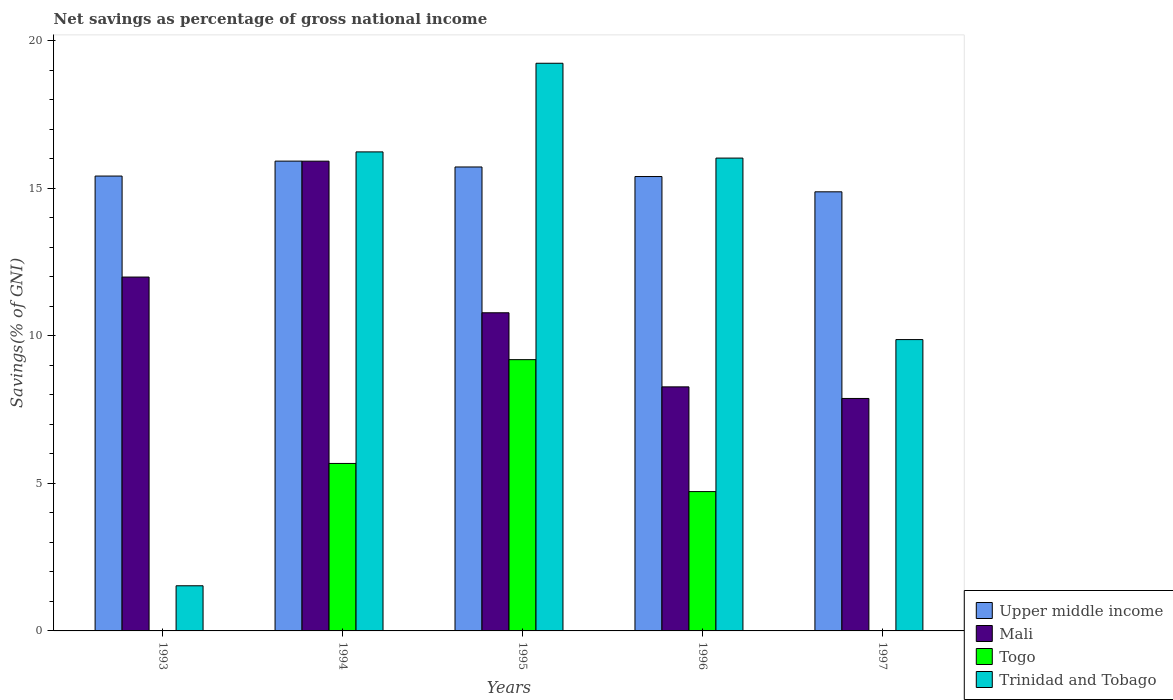Are the number of bars per tick equal to the number of legend labels?
Ensure brevity in your answer.  No. Are the number of bars on each tick of the X-axis equal?
Ensure brevity in your answer.  No. How many bars are there on the 4th tick from the left?
Ensure brevity in your answer.  4. What is the label of the 1st group of bars from the left?
Give a very brief answer. 1993. In how many cases, is the number of bars for a given year not equal to the number of legend labels?
Your answer should be compact. 2. Across all years, what is the maximum total savings in Upper middle income?
Your answer should be compact. 15.91. Across all years, what is the minimum total savings in Mali?
Your response must be concise. 7.87. In which year was the total savings in Mali maximum?
Make the answer very short. 1994. What is the total total savings in Mali in the graph?
Give a very brief answer. 54.82. What is the difference between the total savings in Trinidad and Tobago in 1994 and that in 1996?
Keep it short and to the point. 0.21. What is the difference between the total savings in Mali in 1993 and the total savings in Togo in 1995?
Your answer should be compact. 2.8. What is the average total savings in Mali per year?
Provide a short and direct response. 10.96. In the year 1994, what is the difference between the total savings in Togo and total savings in Mali?
Give a very brief answer. -10.24. In how many years, is the total savings in Trinidad and Tobago greater than 8 %?
Your answer should be very brief. 4. What is the ratio of the total savings in Upper middle income in 1993 to that in 1994?
Provide a succinct answer. 0.97. Is the difference between the total savings in Togo in 1995 and 1996 greater than the difference between the total savings in Mali in 1995 and 1996?
Give a very brief answer. Yes. What is the difference between the highest and the second highest total savings in Trinidad and Tobago?
Your answer should be very brief. 3. What is the difference between the highest and the lowest total savings in Upper middle income?
Keep it short and to the point. 1.04. In how many years, is the total savings in Upper middle income greater than the average total savings in Upper middle income taken over all years?
Make the answer very short. 2. Is the sum of the total savings in Upper middle income in 1995 and 1996 greater than the maximum total savings in Trinidad and Tobago across all years?
Provide a short and direct response. Yes. Is it the case that in every year, the sum of the total savings in Trinidad and Tobago and total savings in Togo is greater than the total savings in Upper middle income?
Provide a succinct answer. No. How many bars are there?
Ensure brevity in your answer.  18. Are all the bars in the graph horizontal?
Your answer should be very brief. No. What is the difference between two consecutive major ticks on the Y-axis?
Your answer should be very brief. 5. How many legend labels are there?
Your answer should be very brief. 4. What is the title of the graph?
Make the answer very short. Net savings as percentage of gross national income. Does "Barbados" appear as one of the legend labels in the graph?
Make the answer very short. No. What is the label or title of the Y-axis?
Keep it short and to the point. Savings(% of GNI). What is the Savings(% of GNI) of Upper middle income in 1993?
Your answer should be compact. 15.41. What is the Savings(% of GNI) of Mali in 1993?
Ensure brevity in your answer.  11.99. What is the Savings(% of GNI) of Togo in 1993?
Offer a terse response. 0. What is the Savings(% of GNI) in Trinidad and Tobago in 1993?
Ensure brevity in your answer.  1.53. What is the Savings(% of GNI) of Upper middle income in 1994?
Your answer should be very brief. 15.91. What is the Savings(% of GNI) in Mali in 1994?
Your answer should be compact. 15.91. What is the Savings(% of GNI) in Togo in 1994?
Make the answer very short. 5.67. What is the Savings(% of GNI) of Trinidad and Tobago in 1994?
Provide a short and direct response. 16.23. What is the Savings(% of GNI) of Upper middle income in 1995?
Offer a very short reply. 15.72. What is the Savings(% of GNI) in Mali in 1995?
Provide a succinct answer. 10.78. What is the Savings(% of GNI) in Togo in 1995?
Keep it short and to the point. 9.19. What is the Savings(% of GNI) in Trinidad and Tobago in 1995?
Give a very brief answer. 19.23. What is the Savings(% of GNI) of Upper middle income in 1996?
Make the answer very short. 15.39. What is the Savings(% of GNI) in Mali in 1996?
Offer a very short reply. 8.27. What is the Savings(% of GNI) of Togo in 1996?
Offer a terse response. 4.72. What is the Savings(% of GNI) of Trinidad and Tobago in 1996?
Give a very brief answer. 16.02. What is the Savings(% of GNI) of Upper middle income in 1997?
Make the answer very short. 14.87. What is the Savings(% of GNI) of Mali in 1997?
Ensure brevity in your answer.  7.87. What is the Savings(% of GNI) of Togo in 1997?
Provide a succinct answer. 0. What is the Savings(% of GNI) of Trinidad and Tobago in 1997?
Give a very brief answer. 9.87. Across all years, what is the maximum Savings(% of GNI) in Upper middle income?
Offer a very short reply. 15.91. Across all years, what is the maximum Savings(% of GNI) in Mali?
Your answer should be compact. 15.91. Across all years, what is the maximum Savings(% of GNI) in Togo?
Provide a succinct answer. 9.19. Across all years, what is the maximum Savings(% of GNI) of Trinidad and Tobago?
Give a very brief answer. 19.23. Across all years, what is the minimum Savings(% of GNI) of Upper middle income?
Provide a short and direct response. 14.87. Across all years, what is the minimum Savings(% of GNI) in Mali?
Provide a succinct answer. 7.87. Across all years, what is the minimum Savings(% of GNI) in Trinidad and Tobago?
Your response must be concise. 1.53. What is the total Savings(% of GNI) in Upper middle income in the graph?
Make the answer very short. 77.3. What is the total Savings(% of GNI) of Mali in the graph?
Ensure brevity in your answer.  54.82. What is the total Savings(% of GNI) of Togo in the graph?
Your answer should be very brief. 19.58. What is the total Savings(% of GNI) of Trinidad and Tobago in the graph?
Provide a succinct answer. 62.87. What is the difference between the Savings(% of GNI) of Upper middle income in 1993 and that in 1994?
Give a very brief answer. -0.51. What is the difference between the Savings(% of GNI) of Mali in 1993 and that in 1994?
Provide a short and direct response. -3.93. What is the difference between the Savings(% of GNI) of Trinidad and Tobago in 1993 and that in 1994?
Provide a short and direct response. -14.7. What is the difference between the Savings(% of GNI) in Upper middle income in 1993 and that in 1995?
Your answer should be compact. -0.31. What is the difference between the Savings(% of GNI) of Mali in 1993 and that in 1995?
Ensure brevity in your answer.  1.21. What is the difference between the Savings(% of GNI) of Trinidad and Tobago in 1993 and that in 1995?
Provide a short and direct response. -17.7. What is the difference between the Savings(% of GNI) in Upper middle income in 1993 and that in 1996?
Offer a very short reply. 0.02. What is the difference between the Savings(% of GNI) of Mali in 1993 and that in 1996?
Ensure brevity in your answer.  3.72. What is the difference between the Savings(% of GNI) in Trinidad and Tobago in 1993 and that in 1996?
Keep it short and to the point. -14.49. What is the difference between the Savings(% of GNI) of Upper middle income in 1993 and that in 1997?
Your answer should be very brief. 0.53. What is the difference between the Savings(% of GNI) in Mali in 1993 and that in 1997?
Give a very brief answer. 4.11. What is the difference between the Savings(% of GNI) of Trinidad and Tobago in 1993 and that in 1997?
Your answer should be very brief. -8.34. What is the difference between the Savings(% of GNI) in Upper middle income in 1994 and that in 1995?
Provide a succinct answer. 0.2. What is the difference between the Savings(% of GNI) of Mali in 1994 and that in 1995?
Keep it short and to the point. 5.14. What is the difference between the Savings(% of GNI) in Togo in 1994 and that in 1995?
Keep it short and to the point. -3.52. What is the difference between the Savings(% of GNI) of Trinidad and Tobago in 1994 and that in 1995?
Keep it short and to the point. -3. What is the difference between the Savings(% of GNI) of Upper middle income in 1994 and that in 1996?
Keep it short and to the point. 0.52. What is the difference between the Savings(% of GNI) in Mali in 1994 and that in 1996?
Keep it short and to the point. 7.65. What is the difference between the Savings(% of GNI) in Togo in 1994 and that in 1996?
Make the answer very short. 0.95. What is the difference between the Savings(% of GNI) in Trinidad and Tobago in 1994 and that in 1996?
Offer a very short reply. 0.21. What is the difference between the Savings(% of GNI) of Upper middle income in 1994 and that in 1997?
Make the answer very short. 1.04. What is the difference between the Savings(% of GNI) in Mali in 1994 and that in 1997?
Offer a terse response. 8.04. What is the difference between the Savings(% of GNI) of Trinidad and Tobago in 1994 and that in 1997?
Provide a succinct answer. 6.36. What is the difference between the Savings(% of GNI) in Upper middle income in 1995 and that in 1996?
Provide a short and direct response. 0.32. What is the difference between the Savings(% of GNI) of Mali in 1995 and that in 1996?
Your response must be concise. 2.51. What is the difference between the Savings(% of GNI) in Togo in 1995 and that in 1996?
Your answer should be very brief. 4.47. What is the difference between the Savings(% of GNI) of Trinidad and Tobago in 1995 and that in 1996?
Offer a very short reply. 3.21. What is the difference between the Savings(% of GNI) of Upper middle income in 1995 and that in 1997?
Provide a succinct answer. 0.84. What is the difference between the Savings(% of GNI) in Mali in 1995 and that in 1997?
Give a very brief answer. 2.9. What is the difference between the Savings(% of GNI) in Trinidad and Tobago in 1995 and that in 1997?
Give a very brief answer. 9.36. What is the difference between the Savings(% of GNI) of Upper middle income in 1996 and that in 1997?
Offer a very short reply. 0.52. What is the difference between the Savings(% of GNI) of Mali in 1996 and that in 1997?
Provide a succinct answer. 0.39. What is the difference between the Savings(% of GNI) of Trinidad and Tobago in 1996 and that in 1997?
Keep it short and to the point. 6.15. What is the difference between the Savings(% of GNI) of Upper middle income in 1993 and the Savings(% of GNI) of Mali in 1994?
Your answer should be compact. -0.5. What is the difference between the Savings(% of GNI) of Upper middle income in 1993 and the Savings(% of GNI) of Togo in 1994?
Provide a short and direct response. 9.73. What is the difference between the Savings(% of GNI) in Upper middle income in 1993 and the Savings(% of GNI) in Trinidad and Tobago in 1994?
Provide a succinct answer. -0.82. What is the difference between the Savings(% of GNI) of Mali in 1993 and the Savings(% of GNI) of Togo in 1994?
Your answer should be very brief. 6.31. What is the difference between the Savings(% of GNI) in Mali in 1993 and the Savings(% of GNI) in Trinidad and Tobago in 1994?
Give a very brief answer. -4.24. What is the difference between the Savings(% of GNI) of Upper middle income in 1993 and the Savings(% of GNI) of Mali in 1995?
Ensure brevity in your answer.  4.63. What is the difference between the Savings(% of GNI) of Upper middle income in 1993 and the Savings(% of GNI) of Togo in 1995?
Offer a very short reply. 6.22. What is the difference between the Savings(% of GNI) in Upper middle income in 1993 and the Savings(% of GNI) in Trinidad and Tobago in 1995?
Provide a succinct answer. -3.82. What is the difference between the Savings(% of GNI) in Mali in 1993 and the Savings(% of GNI) in Togo in 1995?
Your response must be concise. 2.8. What is the difference between the Savings(% of GNI) in Mali in 1993 and the Savings(% of GNI) in Trinidad and Tobago in 1995?
Your response must be concise. -7.24. What is the difference between the Savings(% of GNI) in Upper middle income in 1993 and the Savings(% of GNI) in Mali in 1996?
Your answer should be compact. 7.14. What is the difference between the Savings(% of GNI) of Upper middle income in 1993 and the Savings(% of GNI) of Togo in 1996?
Your response must be concise. 10.69. What is the difference between the Savings(% of GNI) of Upper middle income in 1993 and the Savings(% of GNI) of Trinidad and Tobago in 1996?
Your answer should be compact. -0.61. What is the difference between the Savings(% of GNI) in Mali in 1993 and the Savings(% of GNI) in Togo in 1996?
Give a very brief answer. 7.27. What is the difference between the Savings(% of GNI) in Mali in 1993 and the Savings(% of GNI) in Trinidad and Tobago in 1996?
Give a very brief answer. -4.03. What is the difference between the Savings(% of GNI) of Upper middle income in 1993 and the Savings(% of GNI) of Mali in 1997?
Keep it short and to the point. 7.53. What is the difference between the Savings(% of GNI) of Upper middle income in 1993 and the Savings(% of GNI) of Trinidad and Tobago in 1997?
Offer a terse response. 5.54. What is the difference between the Savings(% of GNI) in Mali in 1993 and the Savings(% of GNI) in Trinidad and Tobago in 1997?
Keep it short and to the point. 2.12. What is the difference between the Savings(% of GNI) of Upper middle income in 1994 and the Savings(% of GNI) of Mali in 1995?
Provide a succinct answer. 5.14. What is the difference between the Savings(% of GNI) in Upper middle income in 1994 and the Savings(% of GNI) in Togo in 1995?
Provide a succinct answer. 6.73. What is the difference between the Savings(% of GNI) of Upper middle income in 1994 and the Savings(% of GNI) of Trinidad and Tobago in 1995?
Your answer should be compact. -3.31. What is the difference between the Savings(% of GNI) in Mali in 1994 and the Savings(% of GNI) in Togo in 1995?
Provide a short and direct response. 6.72. What is the difference between the Savings(% of GNI) of Mali in 1994 and the Savings(% of GNI) of Trinidad and Tobago in 1995?
Ensure brevity in your answer.  -3.32. What is the difference between the Savings(% of GNI) in Togo in 1994 and the Savings(% of GNI) in Trinidad and Tobago in 1995?
Your answer should be compact. -13.56. What is the difference between the Savings(% of GNI) in Upper middle income in 1994 and the Savings(% of GNI) in Mali in 1996?
Make the answer very short. 7.65. What is the difference between the Savings(% of GNI) of Upper middle income in 1994 and the Savings(% of GNI) of Togo in 1996?
Offer a terse response. 11.19. What is the difference between the Savings(% of GNI) in Upper middle income in 1994 and the Savings(% of GNI) in Trinidad and Tobago in 1996?
Your response must be concise. -0.1. What is the difference between the Savings(% of GNI) of Mali in 1994 and the Savings(% of GNI) of Togo in 1996?
Your response must be concise. 11.19. What is the difference between the Savings(% of GNI) of Mali in 1994 and the Savings(% of GNI) of Trinidad and Tobago in 1996?
Provide a succinct answer. -0.1. What is the difference between the Savings(% of GNI) of Togo in 1994 and the Savings(% of GNI) of Trinidad and Tobago in 1996?
Provide a succinct answer. -10.34. What is the difference between the Savings(% of GNI) in Upper middle income in 1994 and the Savings(% of GNI) in Mali in 1997?
Your answer should be compact. 8.04. What is the difference between the Savings(% of GNI) in Upper middle income in 1994 and the Savings(% of GNI) in Trinidad and Tobago in 1997?
Make the answer very short. 6.05. What is the difference between the Savings(% of GNI) in Mali in 1994 and the Savings(% of GNI) in Trinidad and Tobago in 1997?
Your answer should be compact. 6.04. What is the difference between the Savings(% of GNI) of Togo in 1994 and the Savings(% of GNI) of Trinidad and Tobago in 1997?
Offer a terse response. -4.2. What is the difference between the Savings(% of GNI) of Upper middle income in 1995 and the Savings(% of GNI) of Mali in 1996?
Provide a succinct answer. 7.45. What is the difference between the Savings(% of GNI) in Upper middle income in 1995 and the Savings(% of GNI) in Togo in 1996?
Make the answer very short. 11. What is the difference between the Savings(% of GNI) of Upper middle income in 1995 and the Savings(% of GNI) of Trinidad and Tobago in 1996?
Your answer should be very brief. -0.3. What is the difference between the Savings(% of GNI) in Mali in 1995 and the Savings(% of GNI) in Togo in 1996?
Offer a very short reply. 6.06. What is the difference between the Savings(% of GNI) in Mali in 1995 and the Savings(% of GNI) in Trinidad and Tobago in 1996?
Offer a very short reply. -5.24. What is the difference between the Savings(% of GNI) of Togo in 1995 and the Savings(% of GNI) of Trinidad and Tobago in 1996?
Offer a terse response. -6.83. What is the difference between the Savings(% of GNI) of Upper middle income in 1995 and the Savings(% of GNI) of Mali in 1997?
Give a very brief answer. 7.84. What is the difference between the Savings(% of GNI) in Upper middle income in 1995 and the Savings(% of GNI) in Trinidad and Tobago in 1997?
Provide a short and direct response. 5.85. What is the difference between the Savings(% of GNI) in Mali in 1995 and the Savings(% of GNI) in Trinidad and Tobago in 1997?
Offer a terse response. 0.91. What is the difference between the Savings(% of GNI) of Togo in 1995 and the Savings(% of GNI) of Trinidad and Tobago in 1997?
Give a very brief answer. -0.68. What is the difference between the Savings(% of GNI) in Upper middle income in 1996 and the Savings(% of GNI) in Mali in 1997?
Offer a very short reply. 7.52. What is the difference between the Savings(% of GNI) of Upper middle income in 1996 and the Savings(% of GNI) of Trinidad and Tobago in 1997?
Your answer should be very brief. 5.52. What is the difference between the Savings(% of GNI) in Mali in 1996 and the Savings(% of GNI) in Trinidad and Tobago in 1997?
Your response must be concise. -1.6. What is the difference between the Savings(% of GNI) in Togo in 1996 and the Savings(% of GNI) in Trinidad and Tobago in 1997?
Keep it short and to the point. -5.15. What is the average Savings(% of GNI) in Upper middle income per year?
Make the answer very short. 15.46. What is the average Savings(% of GNI) of Mali per year?
Keep it short and to the point. 10.96. What is the average Savings(% of GNI) in Togo per year?
Your answer should be compact. 3.92. What is the average Savings(% of GNI) in Trinidad and Tobago per year?
Offer a terse response. 12.57. In the year 1993, what is the difference between the Savings(% of GNI) of Upper middle income and Savings(% of GNI) of Mali?
Provide a succinct answer. 3.42. In the year 1993, what is the difference between the Savings(% of GNI) in Upper middle income and Savings(% of GNI) in Trinidad and Tobago?
Your response must be concise. 13.88. In the year 1993, what is the difference between the Savings(% of GNI) in Mali and Savings(% of GNI) in Trinidad and Tobago?
Your response must be concise. 10.46. In the year 1994, what is the difference between the Savings(% of GNI) of Upper middle income and Savings(% of GNI) of Mali?
Your answer should be compact. 0. In the year 1994, what is the difference between the Savings(% of GNI) in Upper middle income and Savings(% of GNI) in Togo?
Your answer should be compact. 10.24. In the year 1994, what is the difference between the Savings(% of GNI) in Upper middle income and Savings(% of GNI) in Trinidad and Tobago?
Your answer should be compact. -0.31. In the year 1994, what is the difference between the Savings(% of GNI) of Mali and Savings(% of GNI) of Togo?
Provide a succinct answer. 10.24. In the year 1994, what is the difference between the Savings(% of GNI) in Mali and Savings(% of GNI) in Trinidad and Tobago?
Ensure brevity in your answer.  -0.31. In the year 1994, what is the difference between the Savings(% of GNI) in Togo and Savings(% of GNI) in Trinidad and Tobago?
Provide a short and direct response. -10.55. In the year 1995, what is the difference between the Savings(% of GNI) in Upper middle income and Savings(% of GNI) in Mali?
Your response must be concise. 4.94. In the year 1995, what is the difference between the Savings(% of GNI) in Upper middle income and Savings(% of GNI) in Togo?
Your answer should be very brief. 6.53. In the year 1995, what is the difference between the Savings(% of GNI) of Upper middle income and Savings(% of GNI) of Trinidad and Tobago?
Keep it short and to the point. -3.51. In the year 1995, what is the difference between the Savings(% of GNI) in Mali and Savings(% of GNI) in Togo?
Provide a short and direct response. 1.59. In the year 1995, what is the difference between the Savings(% of GNI) in Mali and Savings(% of GNI) in Trinidad and Tobago?
Keep it short and to the point. -8.45. In the year 1995, what is the difference between the Savings(% of GNI) in Togo and Savings(% of GNI) in Trinidad and Tobago?
Ensure brevity in your answer.  -10.04. In the year 1996, what is the difference between the Savings(% of GNI) in Upper middle income and Savings(% of GNI) in Mali?
Offer a terse response. 7.12. In the year 1996, what is the difference between the Savings(% of GNI) in Upper middle income and Savings(% of GNI) in Togo?
Make the answer very short. 10.67. In the year 1996, what is the difference between the Savings(% of GNI) of Upper middle income and Savings(% of GNI) of Trinidad and Tobago?
Provide a short and direct response. -0.63. In the year 1996, what is the difference between the Savings(% of GNI) in Mali and Savings(% of GNI) in Togo?
Keep it short and to the point. 3.55. In the year 1996, what is the difference between the Savings(% of GNI) of Mali and Savings(% of GNI) of Trinidad and Tobago?
Your answer should be compact. -7.75. In the year 1996, what is the difference between the Savings(% of GNI) of Togo and Savings(% of GNI) of Trinidad and Tobago?
Provide a short and direct response. -11.3. In the year 1997, what is the difference between the Savings(% of GNI) in Upper middle income and Savings(% of GNI) in Mali?
Keep it short and to the point. 7. In the year 1997, what is the difference between the Savings(% of GNI) in Upper middle income and Savings(% of GNI) in Trinidad and Tobago?
Your answer should be very brief. 5.01. In the year 1997, what is the difference between the Savings(% of GNI) in Mali and Savings(% of GNI) in Trinidad and Tobago?
Give a very brief answer. -1.99. What is the ratio of the Savings(% of GNI) in Upper middle income in 1993 to that in 1994?
Your answer should be very brief. 0.97. What is the ratio of the Savings(% of GNI) of Mali in 1993 to that in 1994?
Keep it short and to the point. 0.75. What is the ratio of the Savings(% of GNI) of Trinidad and Tobago in 1993 to that in 1994?
Make the answer very short. 0.09. What is the ratio of the Savings(% of GNI) in Upper middle income in 1993 to that in 1995?
Ensure brevity in your answer.  0.98. What is the ratio of the Savings(% of GNI) of Mali in 1993 to that in 1995?
Your answer should be very brief. 1.11. What is the ratio of the Savings(% of GNI) of Trinidad and Tobago in 1993 to that in 1995?
Keep it short and to the point. 0.08. What is the ratio of the Savings(% of GNI) in Mali in 1993 to that in 1996?
Your answer should be very brief. 1.45. What is the ratio of the Savings(% of GNI) in Trinidad and Tobago in 1993 to that in 1996?
Make the answer very short. 0.1. What is the ratio of the Savings(% of GNI) in Upper middle income in 1993 to that in 1997?
Keep it short and to the point. 1.04. What is the ratio of the Savings(% of GNI) of Mali in 1993 to that in 1997?
Give a very brief answer. 1.52. What is the ratio of the Savings(% of GNI) of Trinidad and Tobago in 1993 to that in 1997?
Offer a very short reply. 0.15. What is the ratio of the Savings(% of GNI) in Upper middle income in 1994 to that in 1995?
Ensure brevity in your answer.  1.01. What is the ratio of the Savings(% of GNI) of Mali in 1994 to that in 1995?
Your response must be concise. 1.48. What is the ratio of the Savings(% of GNI) of Togo in 1994 to that in 1995?
Your response must be concise. 0.62. What is the ratio of the Savings(% of GNI) in Trinidad and Tobago in 1994 to that in 1995?
Provide a succinct answer. 0.84. What is the ratio of the Savings(% of GNI) of Upper middle income in 1994 to that in 1996?
Provide a short and direct response. 1.03. What is the ratio of the Savings(% of GNI) in Mali in 1994 to that in 1996?
Your response must be concise. 1.92. What is the ratio of the Savings(% of GNI) of Togo in 1994 to that in 1996?
Your response must be concise. 1.2. What is the ratio of the Savings(% of GNI) of Trinidad and Tobago in 1994 to that in 1996?
Give a very brief answer. 1.01. What is the ratio of the Savings(% of GNI) of Upper middle income in 1994 to that in 1997?
Give a very brief answer. 1.07. What is the ratio of the Savings(% of GNI) in Mali in 1994 to that in 1997?
Ensure brevity in your answer.  2.02. What is the ratio of the Savings(% of GNI) of Trinidad and Tobago in 1994 to that in 1997?
Your response must be concise. 1.64. What is the ratio of the Savings(% of GNI) in Upper middle income in 1995 to that in 1996?
Make the answer very short. 1.02. What is the ratio of the Savings(% of GNI) in Mali in 1995 to that in 1996?
Give a very brief answer. 1.3. What is the ratio of the Savings(% of GNI) of Togo in 1995 to that in 1996?
Give a very brief answer. 1.95. What is the ratio of the Savings(% of GNI) of Trinidad and Tobago in 1995 to that in 1996?
Your answer should be very brief. 1.2. What is the ratio of the Savings(% of GNI) of Upper middle income in 1995 to that in 1997?
Your answer should be compact. 1.06. What is the ratio of the Savings(% of GNI) of Mali in 1995 to that in 1997?
Give a very brief answer. 1.37. What is the ratio of the Savings(% of GNI) of Trinidad and Tobago in 1995 to that in 1997?
Provide a succinct answer. 1.95. What is the ratio of the Savings(% of GNI) of Upper middle income in 1996 to that in 1997?
Your answer should be very brief. 1.03. What is the ratio of the Savings(% of GNI) of Mali in 1996 to that in 1997?
Offer a very short reply. 1.05. What is the ratio of the Savings(% of GNI) in Trinidad and Tobago in 1996 to that in 1997?
Offer a terse response. 1.62. What is the difference between the highest and the second highest Savings(% of GNI) in Upper middle income?
Keep it short and to the point. 0.2. What is the difference between the highest and the second highest Savings(% of GNI) of Mali?
Your answer should be very brief. 3.93. What is the difference between the highest and the second highest Savings(% of GNI) in Togo?
Your answer should be very brief. 3.52. What is the difference between the highest and the second highest Savings(% of GNI) in Trinidad and Tobago?
Your response must be concise. 3. What is the difference between the highest and the lowest Savings(% of GNI) in Upper middle income?
Your answer should be very brief. 1.04. What is the difference between the highest and the lowest Savings(% of GNI) in Mali?
Your response must be concise. 8.04. What is the difference between the highest and the lowest Savings(% of GNI) in Togo?
Your answer should be very brief. 9.19. What is the difference between the highest and the lowest Savings(% of GNI) of Trinidad and Tobago?
Keep it short and to the point. 17.7. 